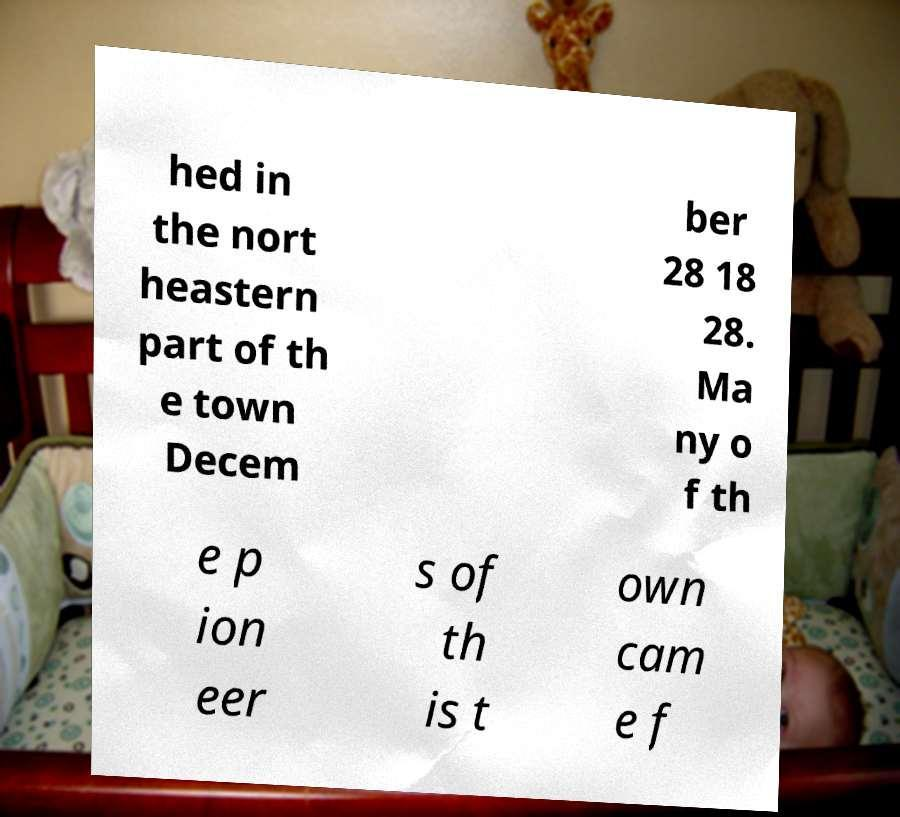I need the written content from this picture converted into text. Can you do that? hed in the nort heastern part of th e town Decem ber 28 18 28. Ma ny o f th e p ion eer s of th is t own cam e f 